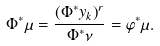<formula> <loc_0><loc_0><loc_500><loc_500>\Phi ^ { * } \mu = \frac { \left ( \Phi ^ { * } y _ { k } \right ) ^ { r } } { \Phi ^ { * } { \nu } } = \varphi ^ { * } \mu .</formula> 